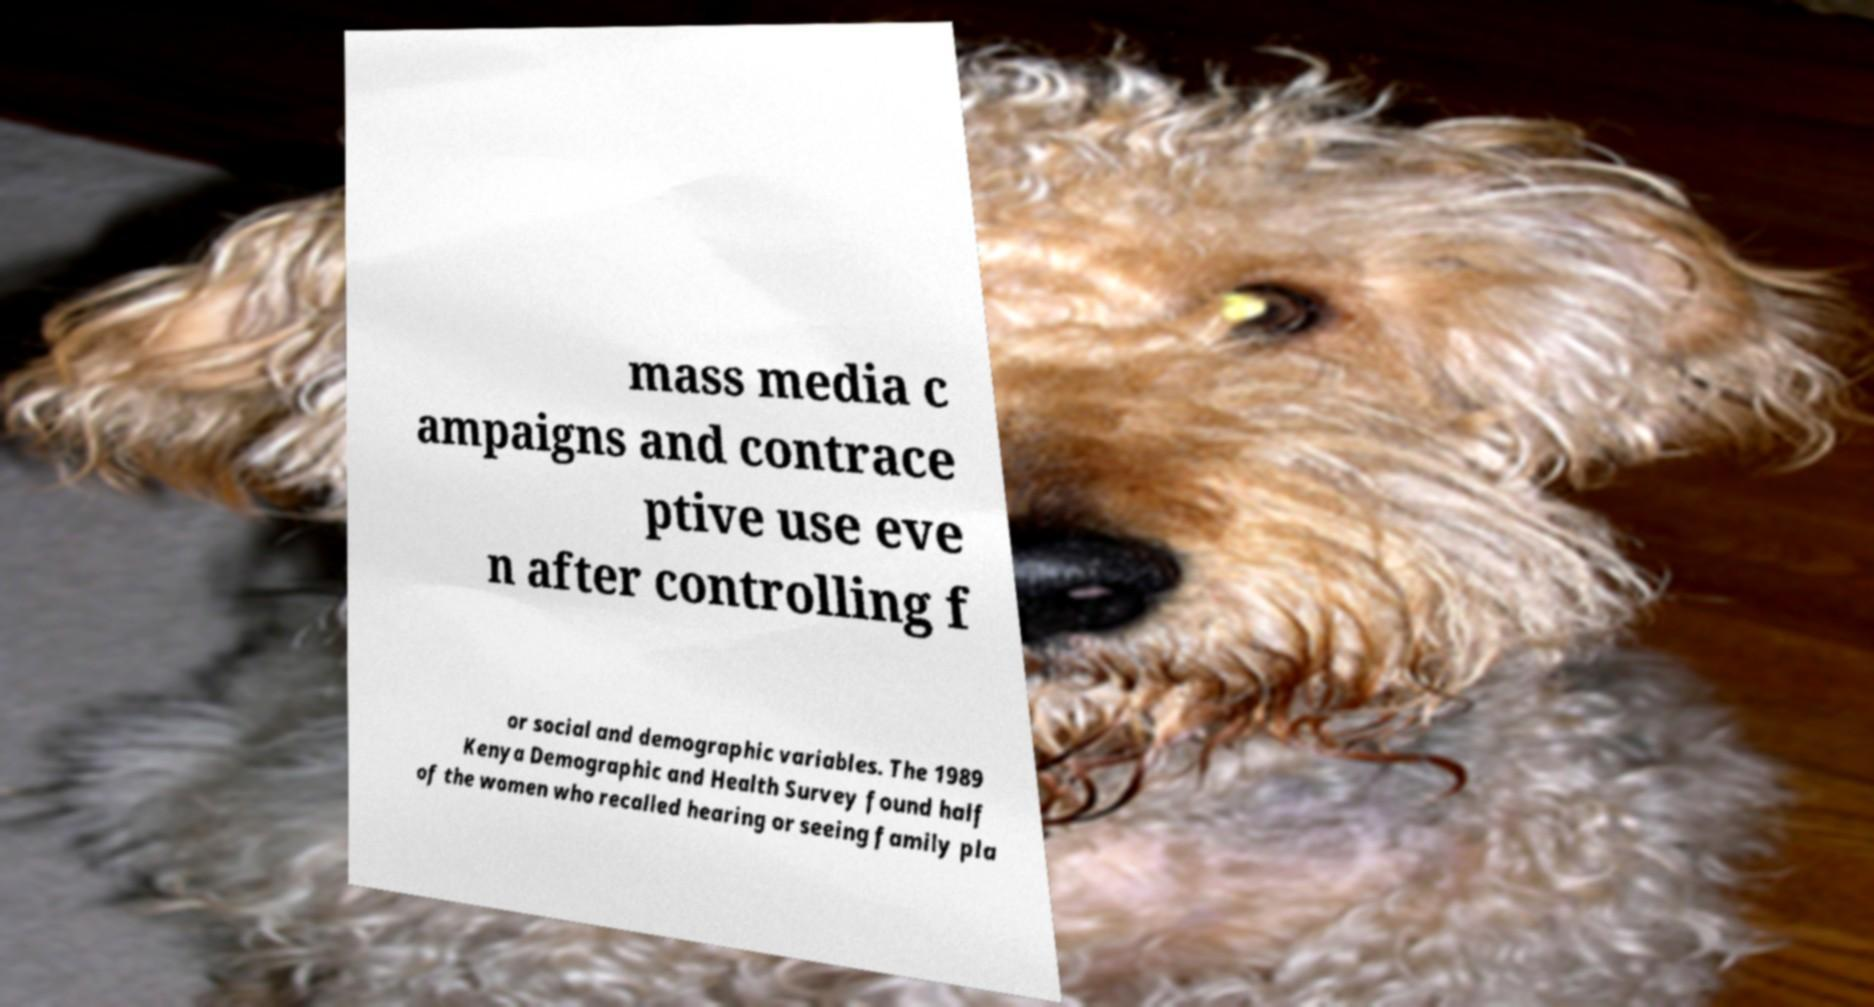I need the written content from this picture converted into text. Can you do that? mass media c ampaigns and contrace ptive use eve n after controlling f or social and demographic variables. The 1989 Kenya Demographic and Health Survey found half of the women who recalled hearing or seeing family pla 